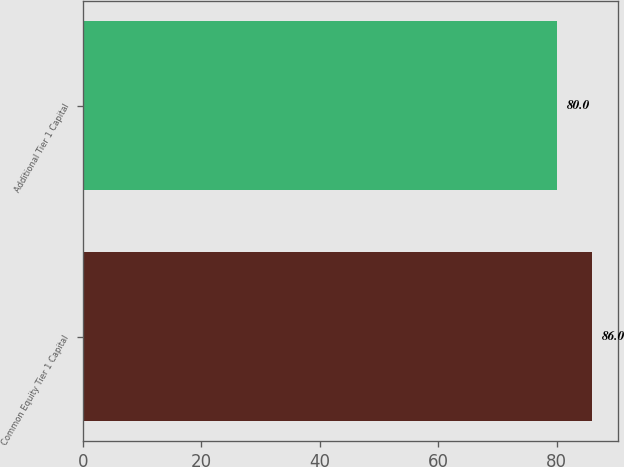Convert chart. <chart><loc_0><loc_0><loc_500><loc_500><bar_chart><fcel>Common Equity Tier 1 Capital<fcel>Additional Tier 1 Capital<nl><fcel>86<fcel>80<nl></chart> 